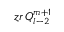Convert formula to latex. <formula><loc_0><loc_0><loc_500><loc_500>z r \, Q _ { l - 2 } ^ { m + 1 }</formula> 